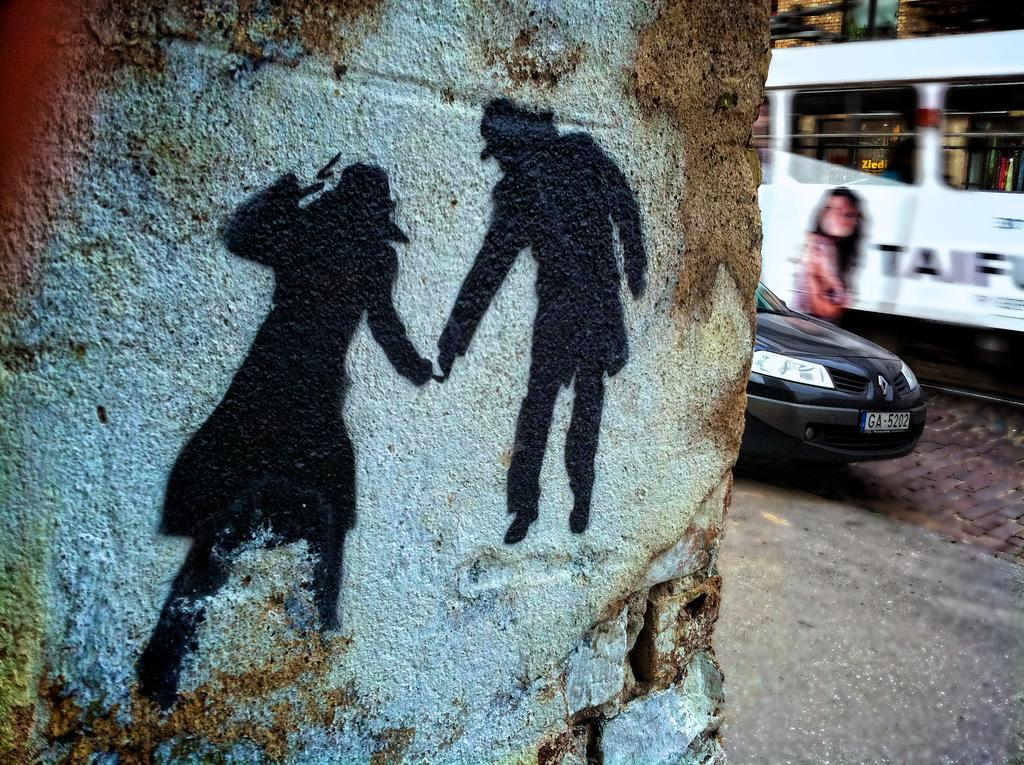What can be seen on the wall in the image? There are shadows on the wall in the image. What is visible in the background of the image? There are vehicles visible in the background of the image. What is located at the bottom of the image? There is a road at the bottom of the image. Can you tell me how many women are attempting to drink the liquid in the image? There is no woman or liquid present in the image; it features shadows on the wall, vehicles in the background, and a road at the bottom. 